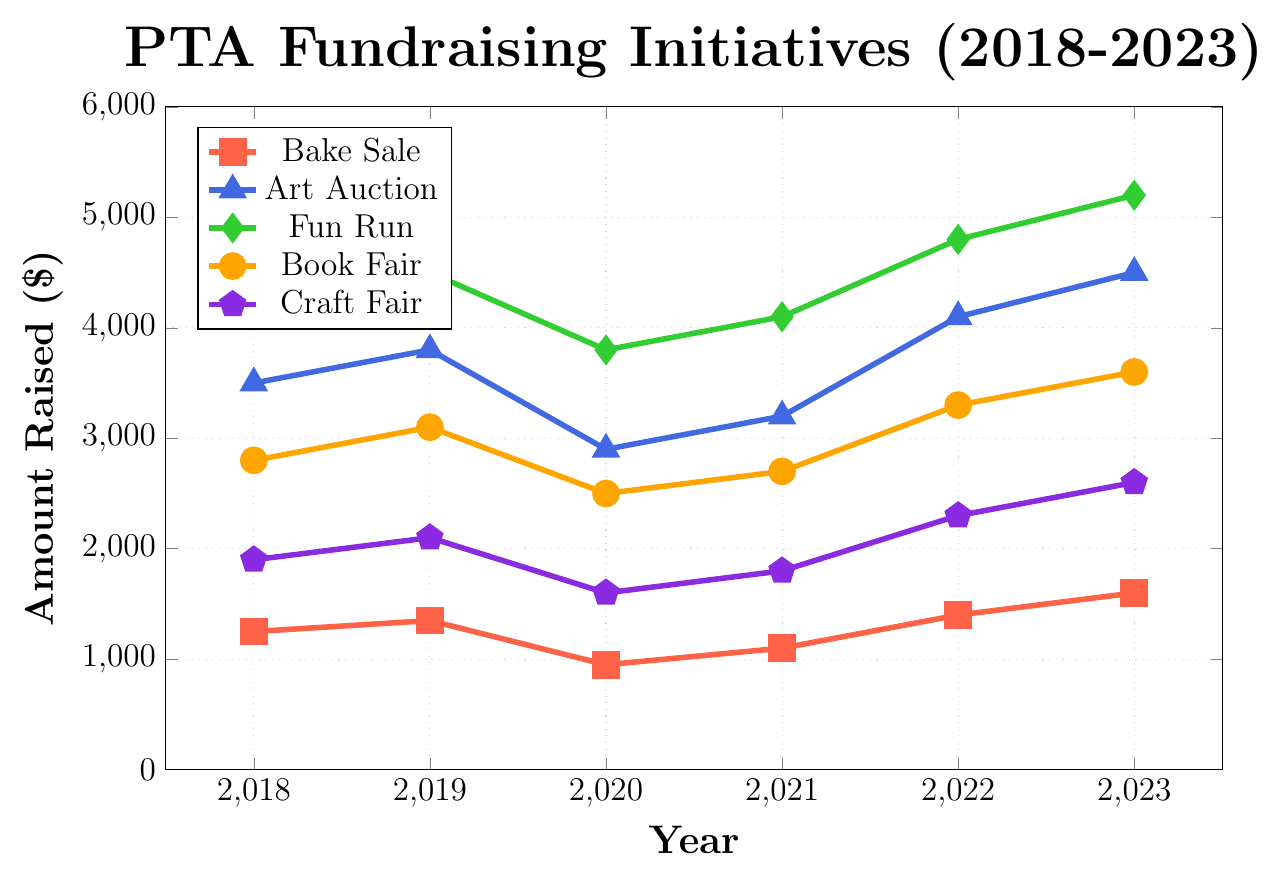What's the trend in the amount raised by the Bake Sale from 2018 to 2023? The Bake Sale started with $1250 in 2018 and showed a general upward trend over the years, reaching $1600 in 2023. The yearly amounts were $1250, $1350, $950, $1100, $1400, and $1600.
Answer: An upward trend Which fundraiser had the highest total amount raised in the given period? Sum the amounts for each initiative and compare: Bake Sale: 1250+1350+950+1100+1400+1600 = 7650, Art Auction: 3500+3800+2900+3200+4100+4500 = 22000, Fun Run: 4200+4500+3800+4100+4800+5200 = 26600, Book Fair: 2800+3100+2500+2700+3300+3600 = 18000, Craft Fair: 1900+2100+1600+1800+2300+2600 = 12300. The Fun Run raised the most.
Answer: Fun Run In which year did the Book Fair raise its highest amount, and how much was it? The Book Fair's highest amount was in 2023, when it raised $3600.
Answer: 2023, $3600 Which fundraiser showed a decline in the amount raised from 2018 to 2020 but then increased until 2023? Examining the data, the Bake Sale declined from $1250 to $950 between 2018 and 2020 but then increased to $1600 in 2023.
Answer: Bake Sale What is the average annual amount raised by the Fun Run over the 6 years? Sum the amounts raised by the Fun Run (4200+4500+3800+4100+4800+5200) = 26600. Divide by 6 years to find the average: 26600 / 6 = 4433.33.
Answer: $4433.33 Compare the amount raised by the Craft Fair in 2023 to the amount raised by the Craft Fair in 2020. The amounts are $2600 in 2023 and $1600 in 2020. Comparing these, $2600 > $1600, so the amount raised in 2023 was higher.
Answer: $2600 > $1600 Which fundraiser had a notable dip in its fundraising amount during the year 2020? The Bake Sale, Art Auction, Fun Run, Book Fair, and Craft Fair all had their fundraising amounts decrease in 2020, but the Art Auction had a large decrease from $3800 in 2019 to $2900 in 2020.
Answer: Art Auction What is the range of amounts raised by the Fun Run over the years? The range is the difference between the maximum and minimum amounts raised: maximum = $5200 in 2023, minimum = $3800 in 2020. Thus, the range is $5200 - $3800 = $1400.
Answer: $1400 How did the Art Auction perform in 2021 compared to its performance in 2018? The Art Auction raised $3200 in 2021 compared to $3500 in 2018. Therefore, it performed worse in 2021 than in 2018.
Answer: Worse in 2021 